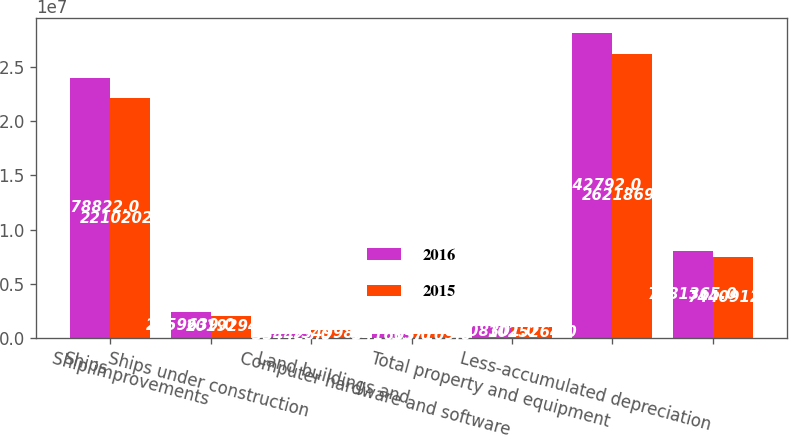<chart> <loc_0><loc_0><loc_500><loc_500><stacked_bar_chart><ecel><fcel>Ships<fcel>Ship improvements<fcel>Ships under construction<fcel>Land buildings and<fcel>Computer hardware and software<fcel>Total property and equipment<fcel>Less-accumulated depreciation<nl><fcel>2016<fcel>2.39788e+07<fcel>2.35964e+06<fcel>354425<fcel>341605<fcel>1.1083e+06<fcel>2.81428e+07<fcel>7.98136e+06<nl><fcel>2015<fcel>2.2102e+07<fcel>2.01929e+06<fcel>734998<fcel>337109<fcel>1.02526e+06<fcel>2.62187e+07<fcel>7.44091e+06<nl></chart> 